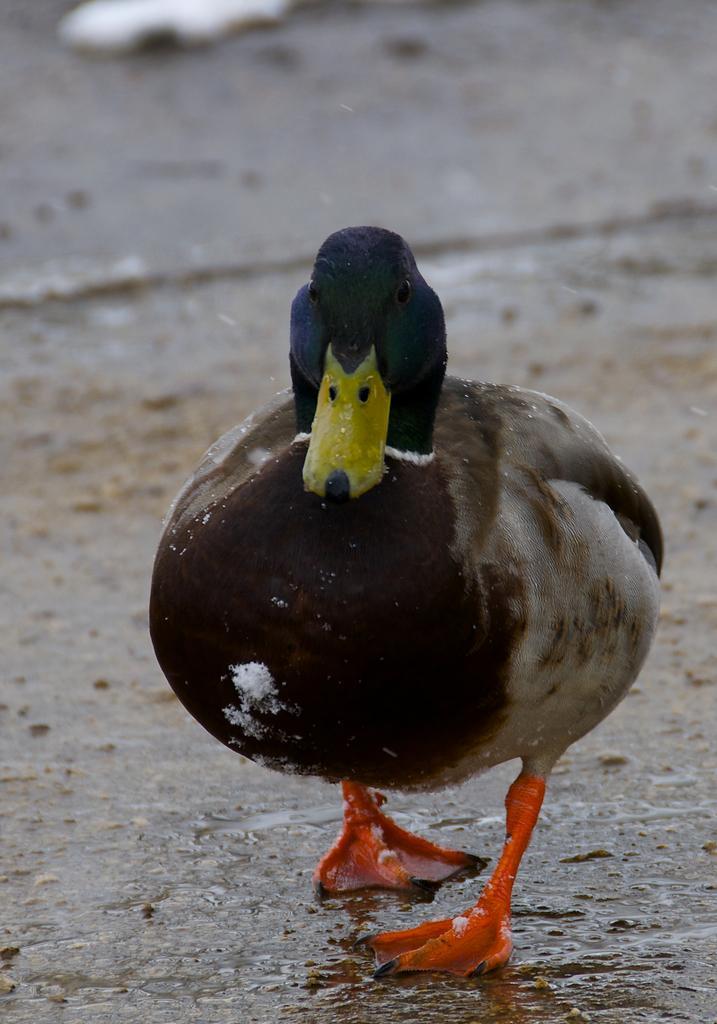Please provide a concise description of this image. In this image we can see a duck standing on the ground. 